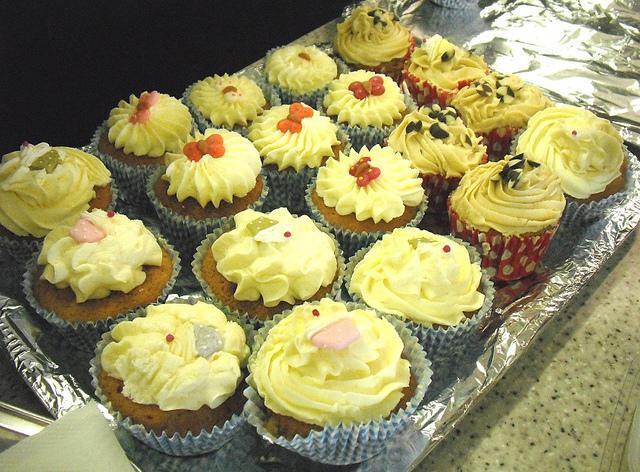How many cupcakes have red liners?
Give a very brief answer. 5. How many cakes are there?
Give a very brief answer. 14. 